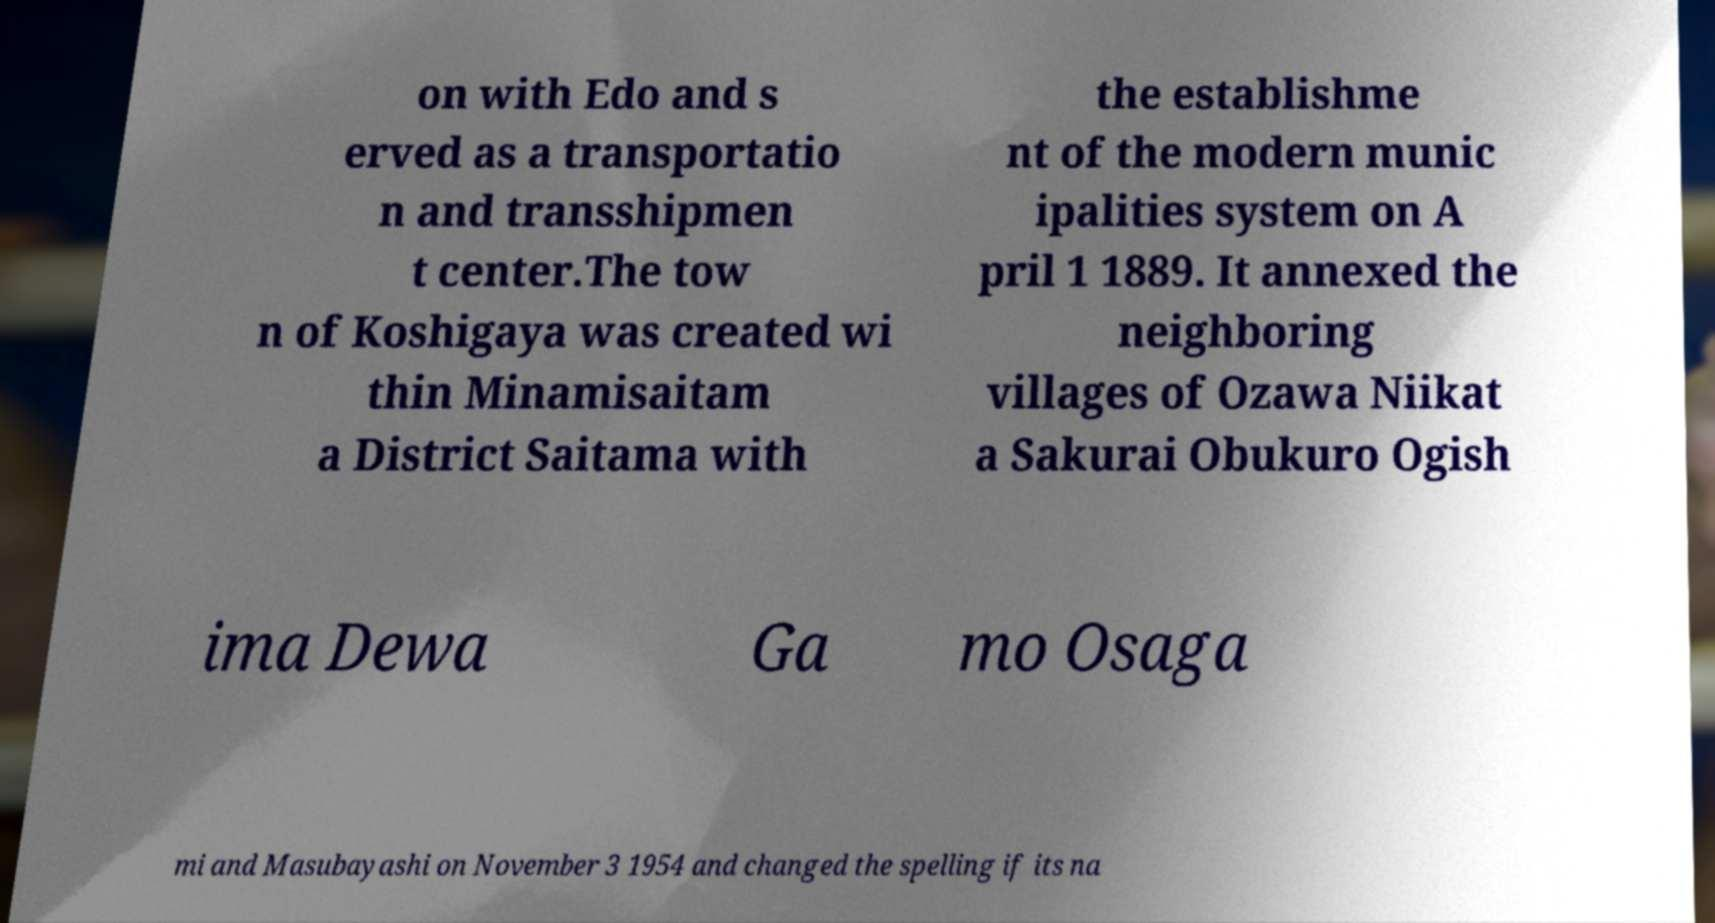Could you assist in decoding the text presented in this image and type it out clearly? on with Edo and s erved as a transportatio n and transshipmen t center.The tow n of Koshigaya was created wi thin Minamisaitam a District Saitama with the establishme nt of the modern munic ipalities system on A pril 1 1889. It annexed the neighboring villages of Ozawa Niikat a Sakurai Obukuro Ogish ima Dewa Ga mo Osaga mi and Masubayashi on November 3 1954 and changed the spelling if its na 